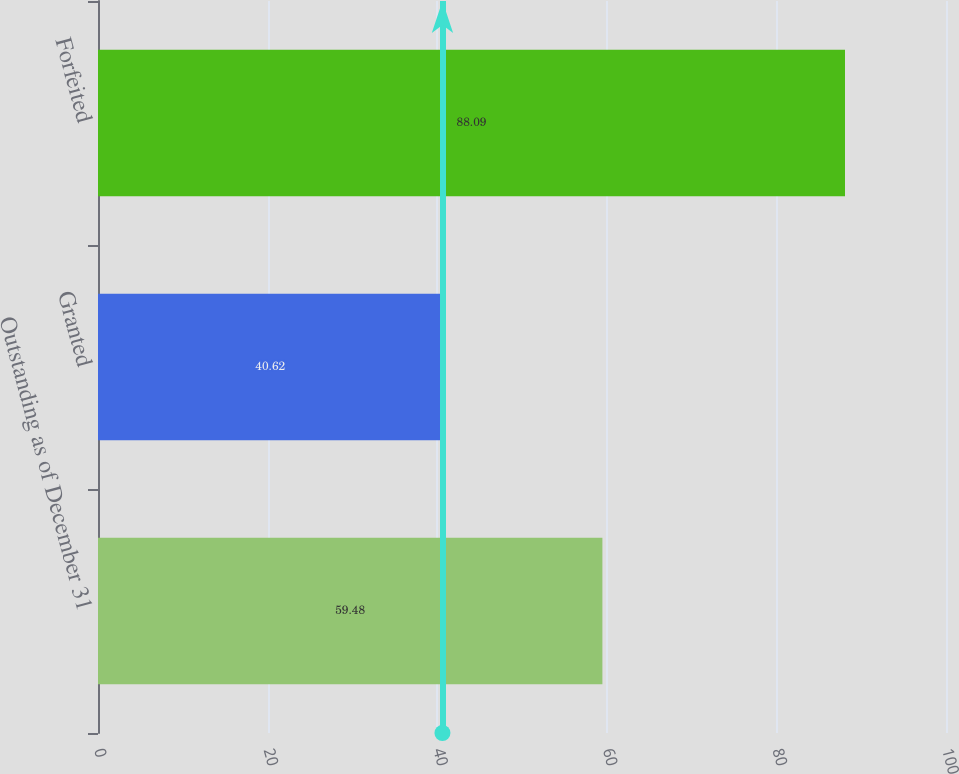Convert chart to OTSL. <chart><loc_0><loc_0><loc_500><loc_500><bar_chart><fcel>Outstanding as of December 31<fcel>Granted<fcel>Forfeited<nl><fcel>59.48<fcel>40.62<fcel>88.09<nl></chart> 